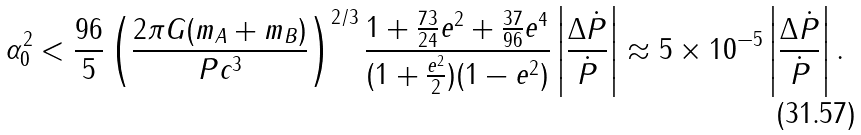<formula> <loc_0><loc_0><loc_500><loc_500>\alpha _ { 0 } ^ { 2 } < \frac { 9 6 } { 5 } \left ( \frac { 2 \pi G ( m _ { A } + m _ { B } ) } { P c ^ { 3 } } \right ) ^ { 2 / 3 } \frac { 1 + \frac { 7 3 } { 2 4 } e ^ { 2 } + \frac { 3 7 } { 9 6 } e ^ { 4 } } { ( 1 + \frac { e ^ { 2 } } { 2 } ) ( 1 - e ^ { 2 } ) } \left | \frac { \Delta \dot { P } } { \dot { P } } \right | \approx 5 \times 1 0 ^ { - 5 } \left | \frac { \Delta \dot { P } } { \dot { P } } \right | .</formula> 